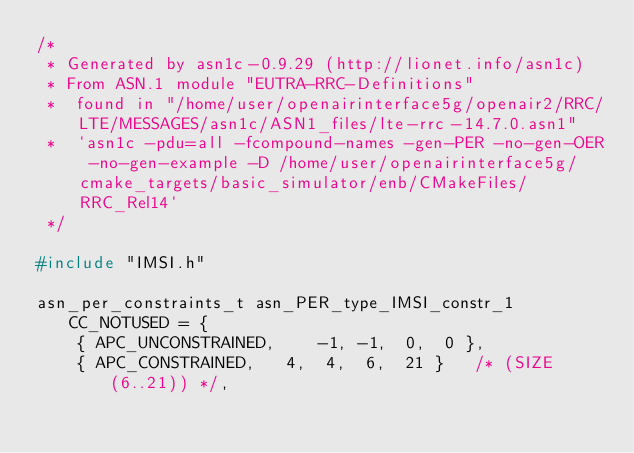<code> <loc_0><loc_0><loc_500><loc_500><_C_>/*
 * Generated by asn1c-0.9.29 (http://lionet.info/asn1c)
 * From ASN.1 module "EUTRA-RRC-Definitions"
 * 	found in "/home/user/openairinterface5g/openair2/RRC/LTE/MESSAGES/asn1c/ASN1_files/lte-rrc-14.7.0.asn1"
 * 	`asn1c -pdu=all -fcompound-names -gen-PER -no-gen-OER -no-gen-example -D /home/user/openairinterface5g/cmake_targets/basic_simulator/enb/CMakeFiles/RRC_Rel14`
 */

#include "IMSI.h"

asn_per_constraints_t asn_PER_type_IMSI_constr_1 CC_NOTUSED = {
	{ APC_UNCONSTRAINED,	-1, -1,  0,  0 },
	{ APC_CONSTRAINED,	 4,  4,  6,  21 }	/* (SIZE(6..21)) */,</code> 